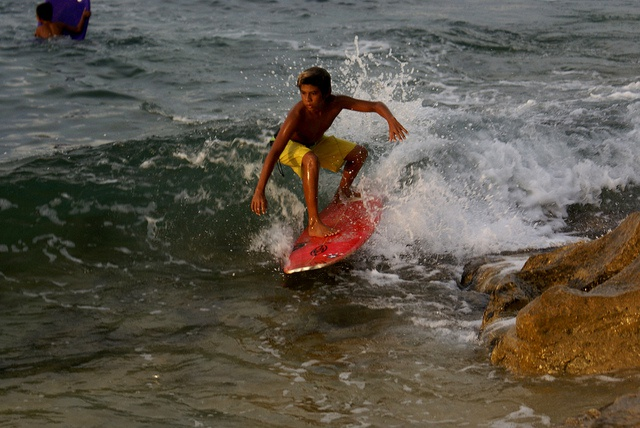Describe the objects in this image and their specific colors. I can see people in gray, black, maroon, brown, and olive tones, surfboard in gray, brown, maroon, and black tones, and people in gray, black, maroon, and navy tones in this image. 